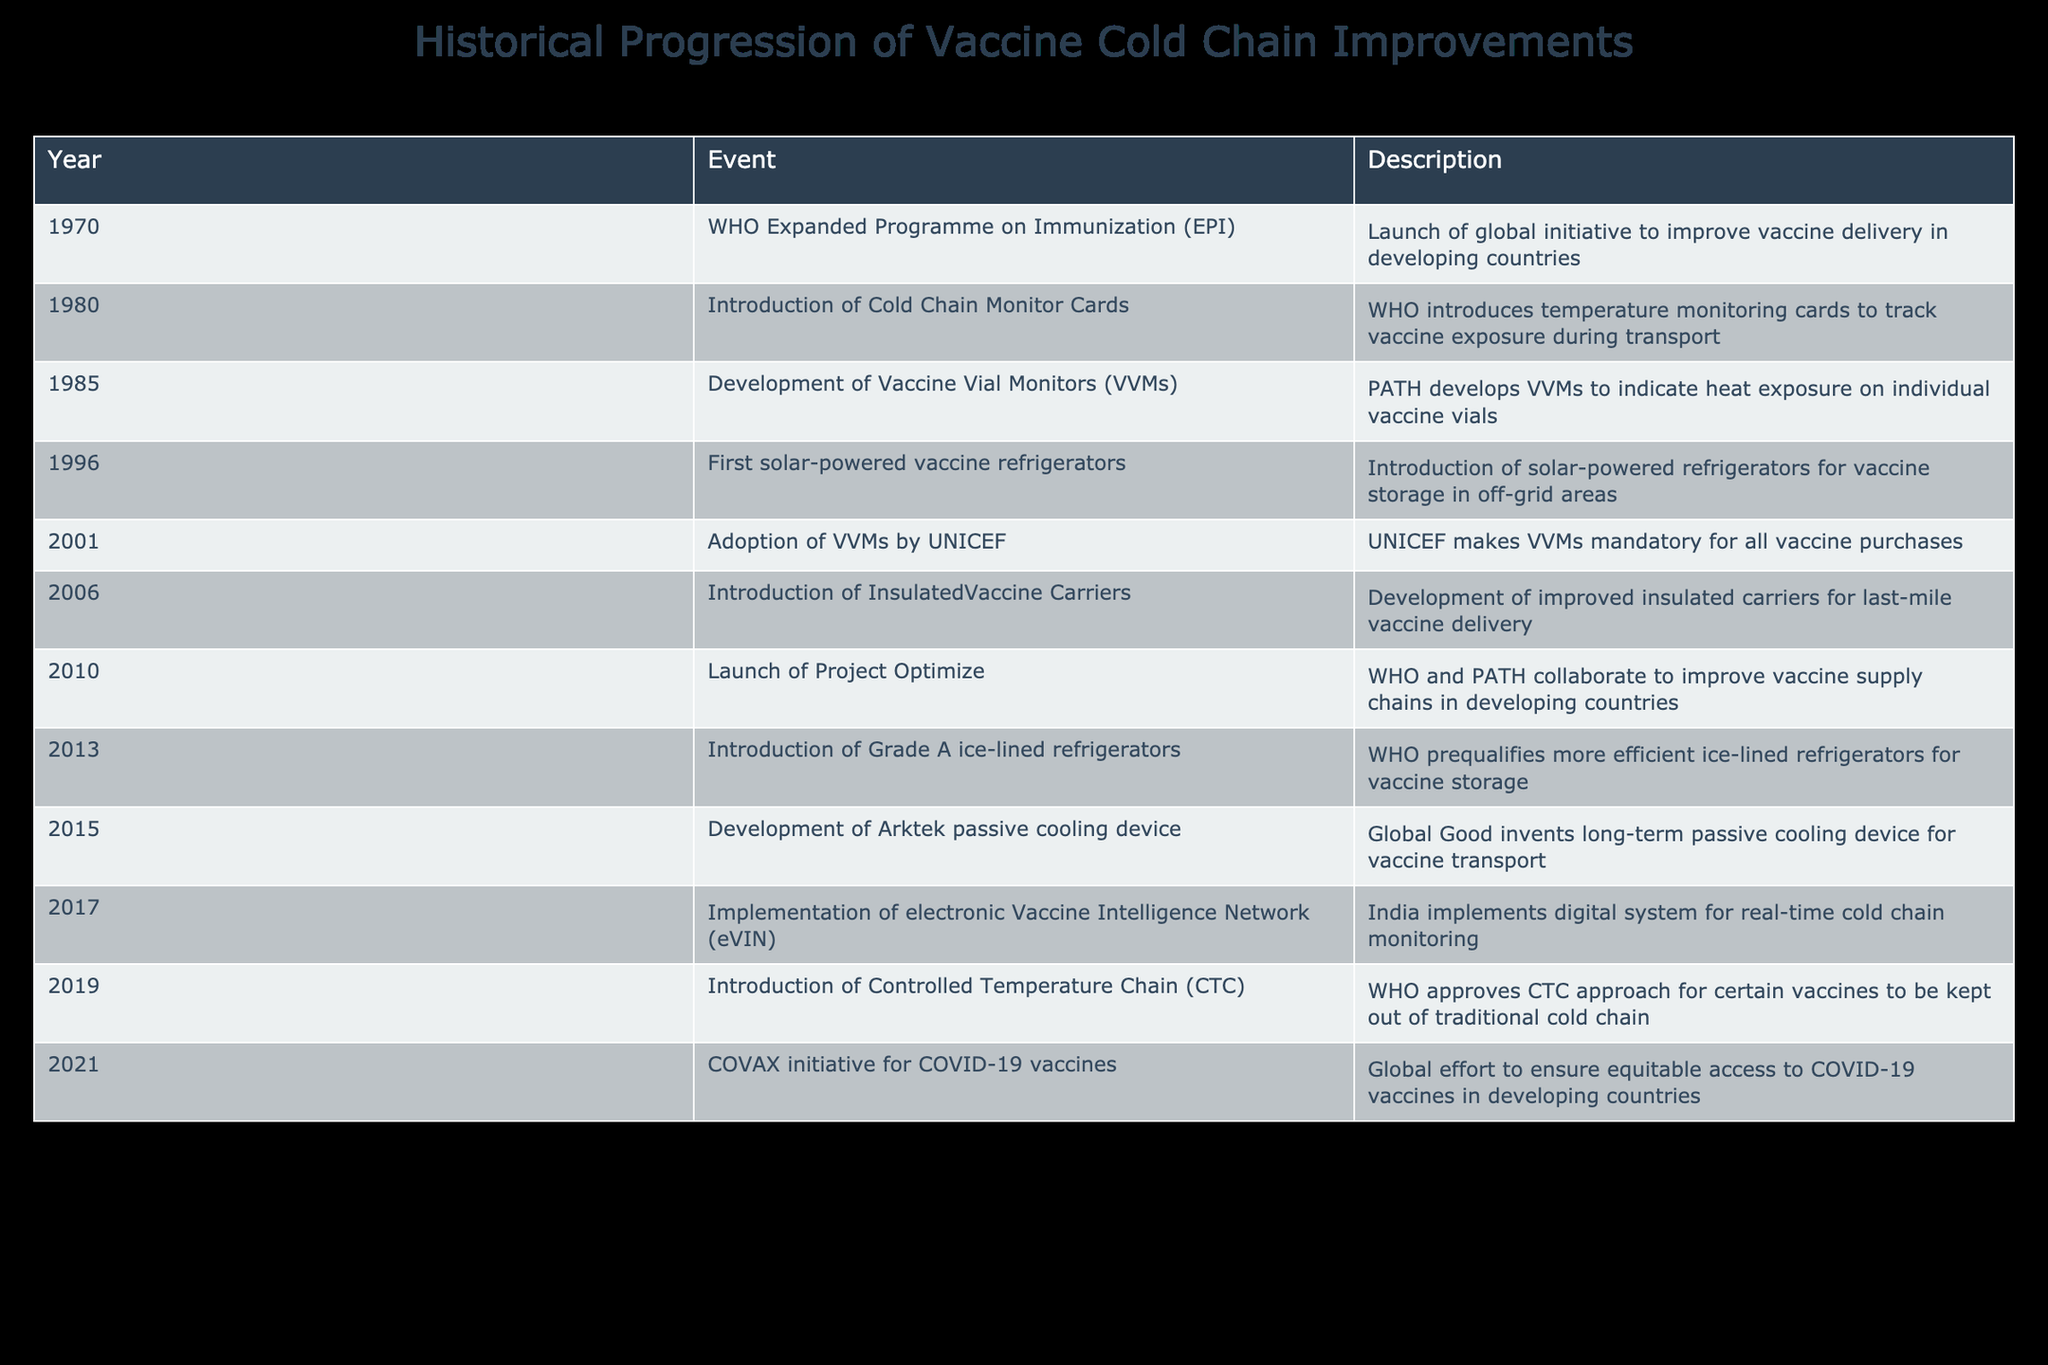What year did the WHO launch the Expanded Programme on Immunization? The table indicates that the WHO launched the Expanded Programme on Immunization in 1970. This is directly stated in the first row of the table.
Answer: 1970 Which organization introduced Cold Chain Monitor Cards in 1980? According to the table, the introduction of Cold Chain Monitor Cards in 1980 was by WHO. This detail is clearly mentioned in the second row.
Answer: WHO How many significant events occurred between 1990 and 2010? Looking at the table, the only significant events that occurred between 1990 and 2010 are the ones listed between 1996 and 2010. There are five events in total during this period (5 events).
Answer: 5 Did UNICEF adopt Vaccine Vial Monitors (VVMs) before 2000? The table clearly states that UNICEF adopted VVMs in 2001. Therefore, the answer is no, as it occurred after 2000.
Answer: No What is the year difference between the introduction of solar-powered vaccine refrigerators and the implementation of eVIN? The introduction of solar-powered vaccine refrigerators was in 1996, and the implementation of eVIN took place in 2017. The difference is 2017 - 1996 = 21 years.
Answer: 21 years What approach did the WHO approve in 2019 related to the vaccine cold chain? The table indicates that in 2019, WHO approved the Controlled Temperature Chain (CTC) approach for certain vaccines. This is detailed in the row for 2019.
Answer: Controlled Temperature Chain (CTC) How many technological improvements related to cold chain monitoring were developed between 1980 and 2015? From the table, counting the relevant events: Cold Chain Monitor Cards (1980), VVMs (1985), and the passive cooling device (2015) gives us a total of 3 technological improvements.
Answer: 3 What event marked the improvement in vaccine storage in 2013? In 2013, the introduction of Grade A ice-lined refrigerators was noted in the table as an important milestone for vaccine storage improvements.
Answer: Introduction of Grade A ice-lined refrigerators What is the chronological order of key events related to vaccine cold chain improvements starting from 1985 to 2021? Looking at the table, the key events in order are: 1985 (Development of VVMs), 2001 (Adoption of VVMs by UNICEF), 2010 (Launch of Project Optimize), 2013 (Introduction of Grade A ice-lined refrigerators), 2015 (Development of Arktek passive cooling device), 2021 (COVAX initiative for COVID-19 vaccines). This list captures the sequence accurately based on years.
Answer: VVM development (1985), UNICEF adoption (2001), Project Optimize (2010), Grade A refrigerators (2013), Arktek device (2015), COVAX initiative (2021) 